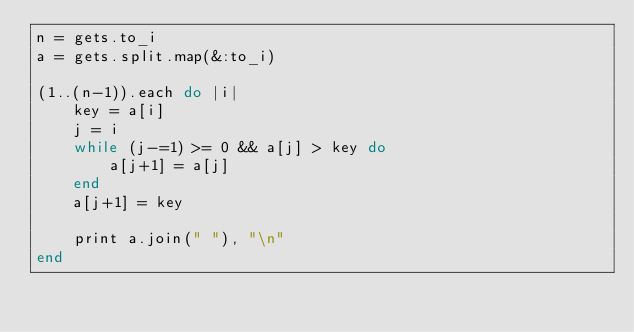<code> <loc_0><loc_0><loc_500><loc_500><_Ruby_>n = gets.to_i
a = gets.split.map(&:to_i)

(1..(n-1)).each do |i|
	key = a[i]
	j = i
	while (j-=1) >= 0 && a[j] > key do
		a[j+1] = a[j]
	end
	a[j+1] = key

	print a.join(" "), "\n"
end</code> 